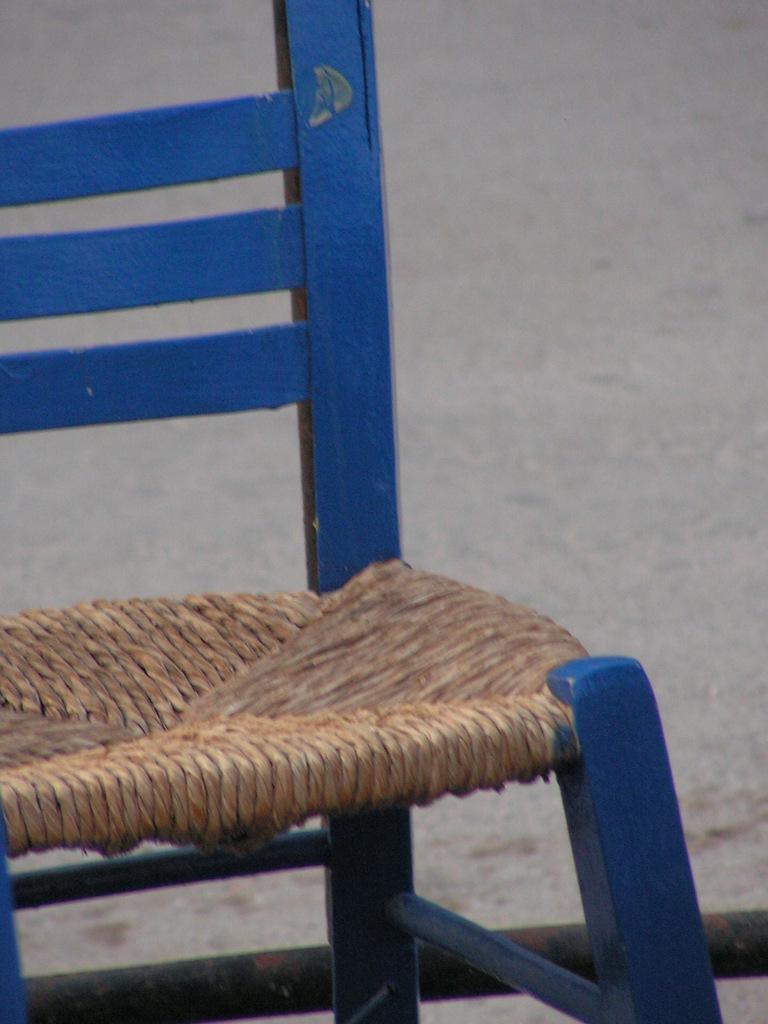In one or two sentences, can you explain what this image depicts? In this image we can see a chair which is truncated. There is a grey color background. 